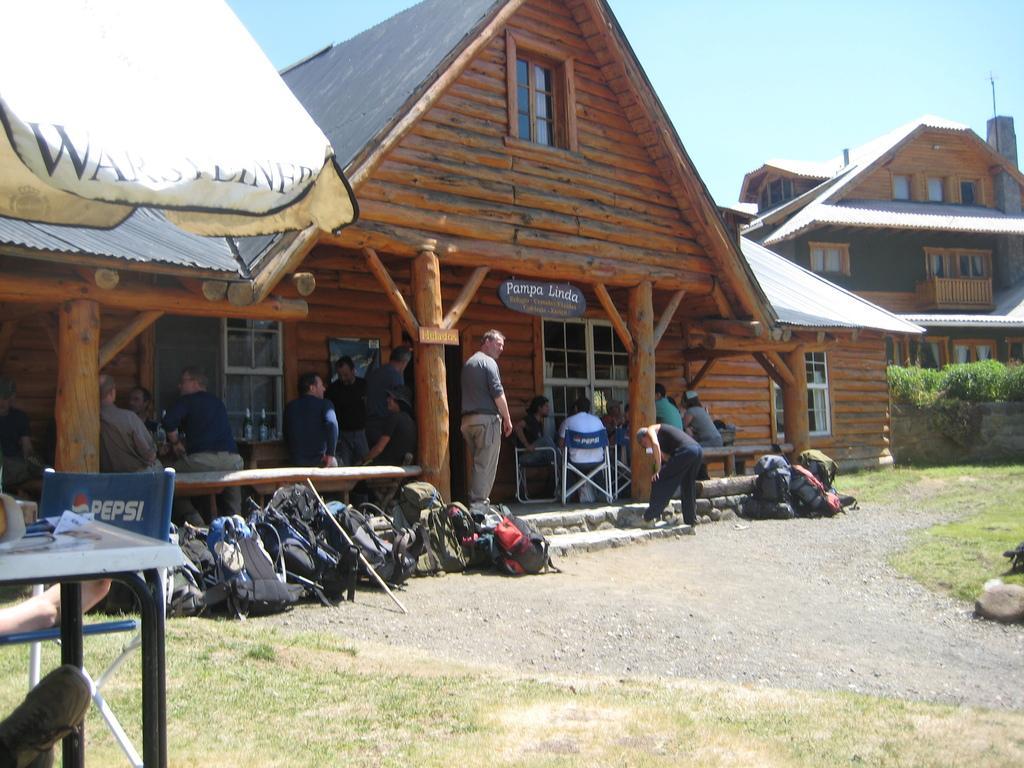Can you describe this image briefly? This picture shows couple of buildings and we see bags on the floor and we see few people seated and few are standing and we see a umbrella and a table and we see grass on the ground and a blue sky and a name board hanging. 